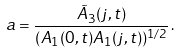Convert formula to latex. <formula><loc_0><loc_0><loc_500><loc_500>a = \frac { \tilde { A } _ { 3 } ( j , t ) } { ( A _ { 1 } ( 0 , t ) A _ { 1 } ( j , t ) ) ^ { 1 / 2 } } \, .</formula> 